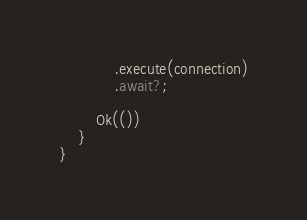Convert code to text. <code><loc_0><loc_0><loc_500><loc_500><_Rust_>            .execute(connection)
            .await?;

        Ok(())
    }
}
</code> 